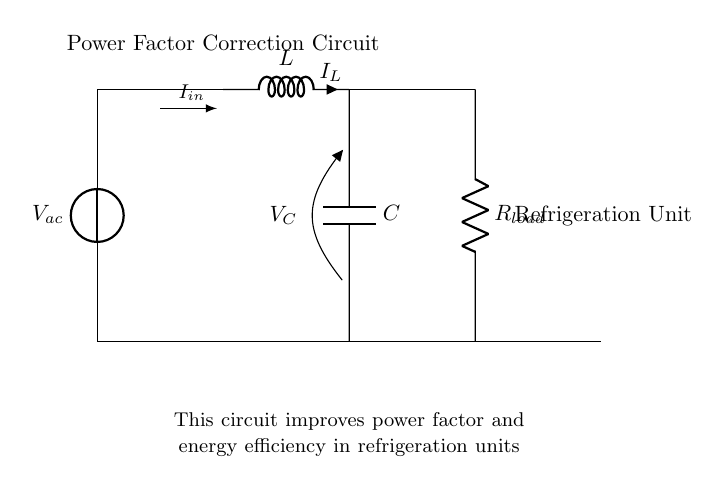What type of circuit is this? This is a power factor correction circuit. The diagram shows components like an inductor, capacitor, and load specifically arranged to improve energy efficiency.
Answer: Power factor correction circuit What component is used to store energy in this circuit? The inductor is used to store energy in a magnetic field when current flows through it. The symbol 'L' represents the inductor in the diagram.
Answer: Inductor What does the capacitor do in this circuit? The capacitor in this circuit is used for power factor correction by compensating for the reactive power drawn by the load. It can reduce voltage drops and improve overall efficiency.
Answer: Compensates for reactive power What is the purpose of the load labeled in the circuit? The load represents the refrigeration unit, which consumes electrical power. It is the device that the circuit is designed to support in terms of energy efficiency.
Answer: Refrigeration unit How does the inductor and capacitor arrangement improve efficiency? The inductor and capacitor work together to balance the reactive power, thus reducing the phase difference between voltage and current. This improves the power factor, leading to better efficiency.
Answer: Balances reactive power What is the current flowing through the inductor labeled as? The current flowing through the inductor is labeled 'I_L' in the diagram, indicating the direction of current and its relationship with the rest of the components.
Answer: I subscript L How does this circuit help with energy costs? By improving the power factor through the inductor and capacitor, this circuit can reduce wasted energy and minimize energy costs associated with poor power factor penalties from utility companies.
Answer: Reduces wasted energy 